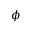<formula> <loc_0><loc_0><loc_500><loc_500>\phi</formula> 